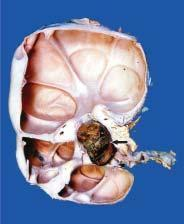what are communicating with the pelvi-calyceal system unlike polycystic kidney?
Answer the question using a single word or phrase. These cysts 